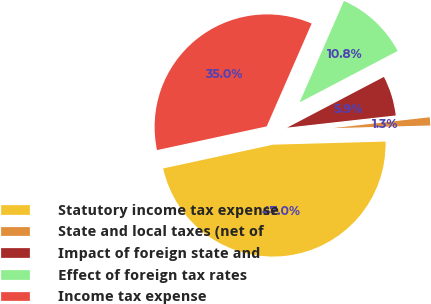Convert chart. <chart><loc_0><loc_0><loc_500><loc_500><pie_chart><fcel>Statutory income tax expense<fcel>State and local taxes (net of<fcel>Impact of foreign state and<fcel>Effect of foreign tax rates<fcel>Income tax expense<nl><fcel>47.04%<fcel>1.34%<fcel>5.91%<fcel>10.75%<fcel>34.95%<nl></chart> 